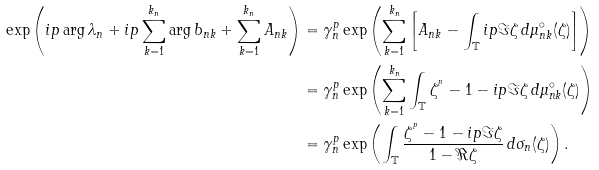<formula> <loc_0><loc_0><loc_500><loc_500>\exp \left ( i p \arg \lambda _ { n } + i p \sum _ { k = 1 } ^ { k _ { n } } \arg b _ { n k } + \sum _ { k = 1 } ^ { k _ { n } } A _ { n k } \right ) & = \gamma _ { n } ^ { p } \exp \left ( \sum _ { k = 1 } ^ { k _ { n } } \left [ A _ { n k } - \int _ { \mathbb { T } } i p \Im \zeta \, d \mu _ { n k } ^ { \circ } ( \zeta ) \right ] \right ) \\ & = \gamma _ { n } ^ { p } \exp \left ( \sum _ { k = 1 } ^ { k _ { n } } \int _ { \mathbb { T } } \zeta ^ { ^ { p } } - 1 - i p \Im \zeta \, d \mu _ { n k } ^ { \circ } ( \zeta ) \right ) \\ & = \gamma _ { n } ^ { p } \exp \left ( \int _ { \mathbb { T } } \frac { \zeta ^ { ^ { p } } - 1 - i p \Im \zeta } { 1 - \Re \zeta } \, d \sigma _ { n } ( \zeta ) \right ) .</formula> 